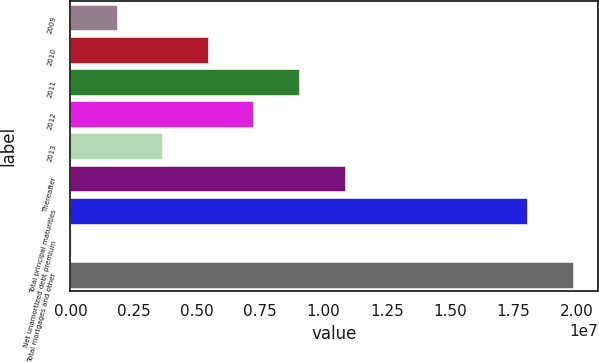<chart> <loc_0><loc_0><loc_500><loc_500><bar_chart><fcel>2009<fcel>2010<fcel>2011<fcel>2012<fcel>2013<fcel>Thereafter<fcel>Total principal maturities<fcel>Net unamortized debt premium<fcel>Total mortgages and other<nl><fcel>1.81973e+06<fcel>5.4248e+06<fcel>9.02987e+06<fcel>7.22733e+06<fcel>3.62227e+06<fcel>1.08324e+07<fcel>1.80253e+07<fcel>17199<fcel>1.98279e+07<nl></chart> 